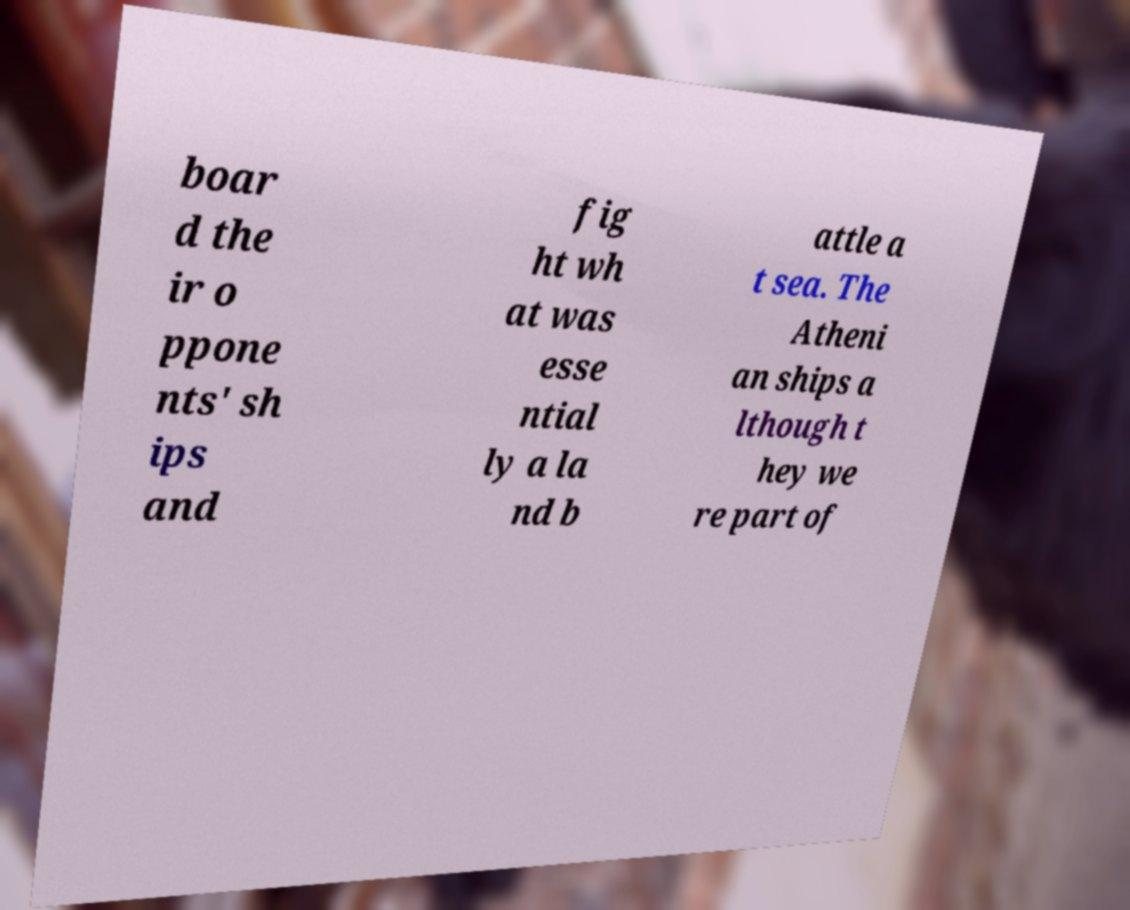Please identify and transcribe the text found in this image. boar d the ir o ppone nts' sh ips and fig ht wh at was esse ntial ly a la nd b attle a t sea. The Atheni an ships a lthough t hey we re part of 